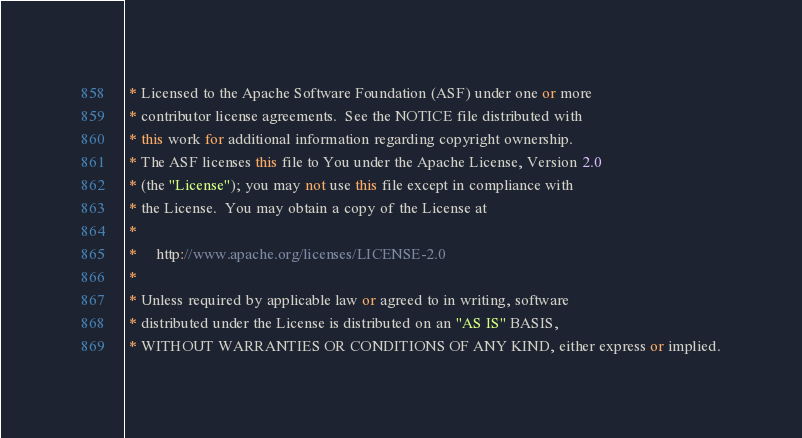<code> <loc_0><loc_0><loc_500><loc_500><_C++_> * Licensed to the Apache Software Foundation (ASF) under one or more
 * contributor license agreements.  See the NOTICE file distributed with
 * this work for additional information regarding copyright ownership.
 * The ASF licenses this file to You under the Apache License, Version 2.0
 * (the "License"); you may not use this file except in compliance with
 * the License.  You may obtain a copy of the License at
 *
 *     http://www.apache.org/licenses/LICENSE-2.0
 *
 * Unless required by applicable law or agreed to in writing, software
 * distributed under the License is distributed on an "AS IS" BASIS,
 * WITHOUT WARRANTIES OR CONDITIONS OF ANY KIND, either express or implied.</code> 